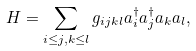Convert formula to latex. <formula><loc_0><loc_0><loc_500><loc_500>H = \sum _ { i \leq j , k \leq l } g _ { i j k l } a ^ { \dagger } _ { i } a ^ { \dagger } _ { j } a _ { k } a _ { l } ,</formula> 